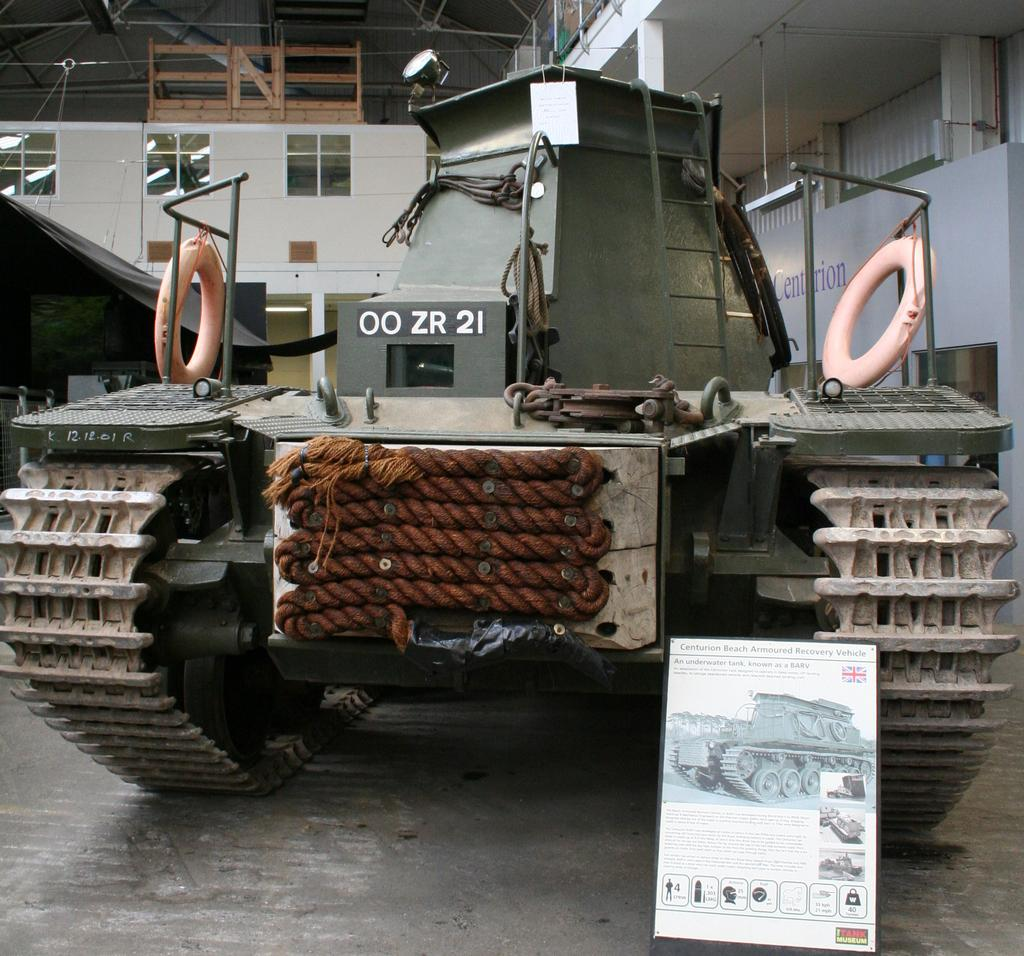What type of vehicle is in the image? There is a panzer tank in the image. Where is the panzer tank located? The panzer tank is placed on the floor. What is the board in the image used for? The board in the image has images on it, which suggests it might be used for displaying information or artwork. What can be seen in the background of the image? There is a wall, pillars, lights, a shed, and rods in the background of the image. What type of house is visible in the image? There is no house present in the image. What territory does the wren occupy in the image? There is no wren present in the image. 